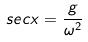Convert formula to latex. <formula><loc_0><loc_0><loc_500><loc_500>s e c x = \frac { g } { \omega ^ { 2 } }</formula> 